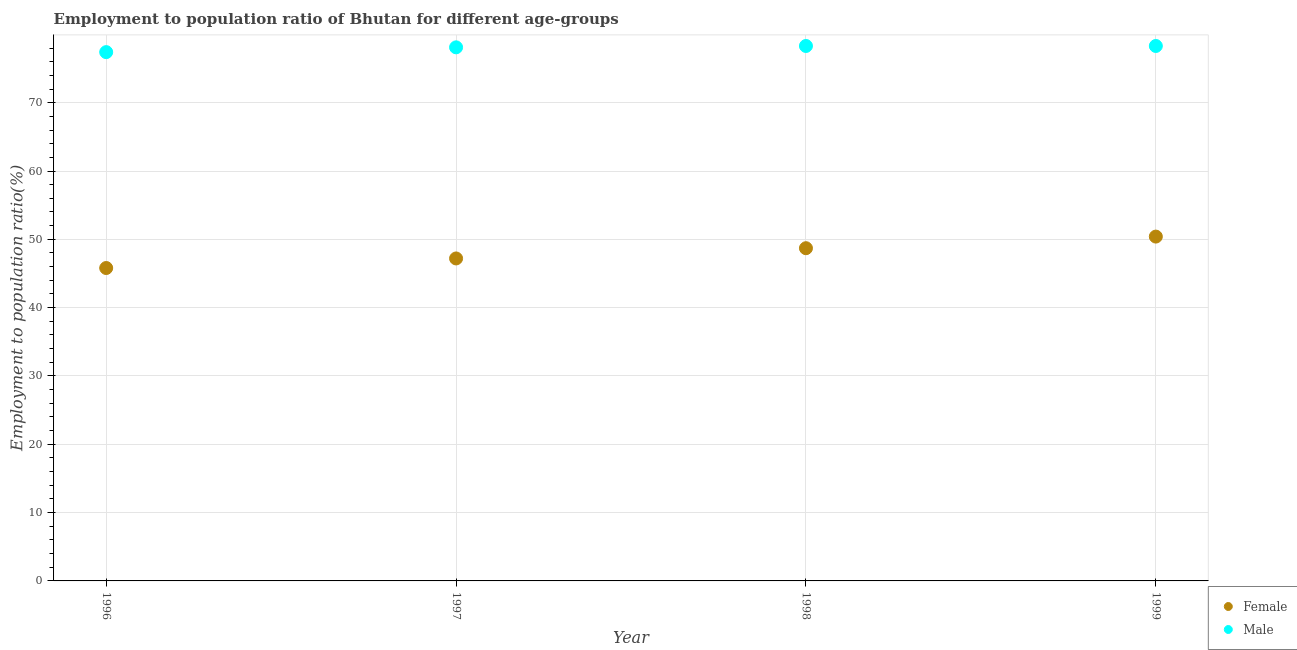How many different coloured dotlines are there?
Your response must be concise. 2. Is the number of dotlines equal to the number of legend labels?
Offer a very short reply. Yes. What is the employment to population ratio(female) in 1997?
Offer a very short reply. 47.2. Across all years, what is the maximum employment to population ratio(female)?
Offer a terse response. 50.4. Across all years, what is the minimum employment to population ratio(male)?
Your answer should be compact. 77.4. In which year was the employment to population ratio(male) maximum?
Give a very brief answer. 1998. In which year was the employment to population ratio(female) minimum?
Provide a succinct answer. 1996. What is the total employment to population ratio(male) in the graph?
Offer a terse response. 312.1. What is the difference between the employment to population ratio(female) in 1996 and that in 1997?
Your answer should be very brief. -1.4. What is the difference between the employment to population ratio(female) in 1999 and the employment to population ratio(male) in 1998?
Make the answer very short. -27.9. What is the average employment to population ratio(female) per year?
Ensure brevity in your answer.  48.03. In the year 1997, what is the difference between the employment to population ratio(male) and employment to population ratio(female)?
Make the answer very short. 30.9. What is the ratio of the employment to population ratio(female) in 1997 to that in 1999?
Offer a terse response. 0.94. Is the employment to population ratio(male) in 1996 less than that in 1998?
Offer a terse response. Yes. What is the difference between the highest and the second highest employment to population ratio(female)?
Offer a terse response. 1.7. What is the difference between the highest and the lowest employment to population ratio(male)?
Your answer should be very brief. 0.9. In how many years, is the employment to population ratio(female) greater than the average employment to population ratio(female) taken over all years?
Keep it short and to the point. 2. Is the sum of the employment to population ratio(female) in 1998 and 1999 greater than the maximum employment to population ratio(male) across all years?
Keep it short and to the point. Yes. Does the employment to population ratio(male) monotonically increase over the years?
Keep it short and to the point. No. Is the employment to population ratio(male) strictly greater than the employment to population ratio(female) over the years?
Offer a terse response. Yes. How many dotlines are there?
Your answer should be compact. 2. Are the values on the major ticks of Y-axis written in scientific E-notation?
Ensure brevity in your answer.  No. Does the graph contain any zero values?
Offer a terse response. No. Where does the legend appear in the graph?
Offer a very short reply. Bottom right. How many legend labels are there?
Offer a terse response. 2. What is the title of the graph?
Give a very brief answer. Employment to population ratio of Bhutan for different age-groups. What is the Employment to population ratio(%) in Female in 1996?
Provide a short and direct response. 45.8. What is the Employment to population ratio(%) in Male in 1996?
Give a very brief answer. 77.4. What is the Employment to population ratio(%) in Female in 1997?
Offer a very short reply. 47.2. What is the Employment to population ratio(%) in Male in 1997?
Keep it short and to the point. 78.1. What is the Employment to population ratio(%) of Female in 1998?
Keep it short and to the point. 48.7. What is the Employment to population ratio(%) in Male in 1998?
Your answer should be very brief. 78.3. What is the Employment to population ratio(%) of Female in 1999?
Make the answer very short. 50.4. What is the Employment to population ratio(%) in Male in 1999?
Give a very brief answer. 78.3. Across all years, what is the maximum Employment to population ratio(%) of Female?
Your answer should be compact. 50.4. Across all years, what is the maximum Employment to population ratio(%) in Male?
Provide a short and direct response. 78.3. Across all years, what is the minimum Employment to population ratio(%) in Female?
Give a very brief answer. 45.8. Across all years, what is the minimum Employment to population ratio(%) of Male?
Give a very brief answer. 77.4. What is the total Employment to population ratio(%) of Female in the graph?
Keep it short and to the point. 192.1. What is the total Employment to population ratio(%) of Male in the graph?
Offer a terse response. 312.1. What is the difference between the Employment to population ratio(%) of Female in 1996 and that in 1997?
Offer a very short reply. -1.4. What is the difference between the Employment to population ratio(%) of Male in 1996 and that in 1997?
Make the answer very short. -0.7. What is the difference between the Employment to population ratio(%) of Female in 1996 and that in 1998?
Your answer should be compact. -2.9. What is the difference between the Employment to population ratio(%) of Male in 1996 and that in 1998?
Your answer should be very brief. -0.9. What is the difference between the Employment to population ratio(%) of Female in 1996 and that in 1999?
Offer a terse response. -4.6. What is the difference between the Employment to population ratio(%) of Male in 1996 and that in 1999?
Ensure brevity in your answer.  -0.9. What is the difference between the Employment to population ratio(%) in Male in 1997 and that in 1999?
Make the answer very short. -0.2. What is the difference between the Employment to population ratio(%) in Male in 1998 and that in 1999?
Give a very brief answer. 0. What is the difference between the Employment to population ratio(%) in Female in 1996 and the Employment to population ratio(%) in Male in 1997?
Provide a short and direct response. -32.3. What is the difference between the Employment to population ratio(%) in Female in 1996 and the Employment to population ratio(%) in Male in 1998?
Offer a very short reply. -32.5. What is the difference between the Employment to population ratio(%) in Female in 1996 and the Employment to population ratio(%) in Male in 1999?
Keep it short and to the point. -32.5. What is the difference between the Employment to population ratio(%) of Female in 1997 and the Employment to population ratio(%) of Male in 1998?
Give a very brief answer. -31.1. What is the difference between the Employment to population ratio(%) in Female in 1997 and the Employment to population ratio(%) in Male in 1999?
Offer a very short reply. -31.1. What is the difference between the Employment to population ratio(%) in Female in 1998 and the Employment to population ratio(%) in Male in 1999?
Offer a very short reply. -29.6. What is the average Employment to population ratio(%) in Female per year?
Keep it short and to the point. 48.02. What is the average Employment to population ratio(%) of Male per year?
Offer a terse response. 78.03. In the year 1996, what is the difference between the Employment to population ratio(%) of Female and Employment to population ratio(%) of Male?
Offer a very short reply. -31.6. In the year 1997, what is the difference between the Employment to population ratio(%) in Female and Employment to population ratio(%) in Male?
Give a very brief answer. -30.9. In the year 1998, what is the difference between the Employment to population ratio(%) in Female and Employment to population ratio(%) in Male?
Keep it short and to the point. -29.6. In the year 1999, what is the difference between the Employment to population ratio(%) in Female and Employment to population ratio(%) in Male?
Make the answer very short. -27.9. What is the ratio of the Employment to population ratio(%) of Female in 1996 to that in 1997?
Your answer should be compact. 0.97. What is the ratio of the Employment to population ratio(%) of Male in 1996 to that in 1997?
Give a very brief answer. 0.99. What is the ratio of the Employment to population ratio(%) in Female in 1996 to that in 1998?
Offer a terse response. 0.94. What is the ratio of the Employment to population ratio(%) in Female in 1996 to that in 1999?
Offer a very short reply. 0.91. What is the ratio of the Employment to population ratio(%) in Female in 1997 to that in 1998?
Keep it short and to the point. 0.97. What is the ratio of the Employment to population ratio(%) of Female in 1997 to that in 1999?
Keep it short and to the point. 0.94. What is the ratio of the Employment to population ratio(%) in Female in 1998 to that in 1999?
Your answer should be compact. 0.97. What is the difference between the highest and the second highest Employment to population ratio(%) of Male?
Ensure brevity in your answer.  0. What is the difference between the highest and the lowest Employment to population ratio(%) in Male?
Your response must be concise. 0.9. 